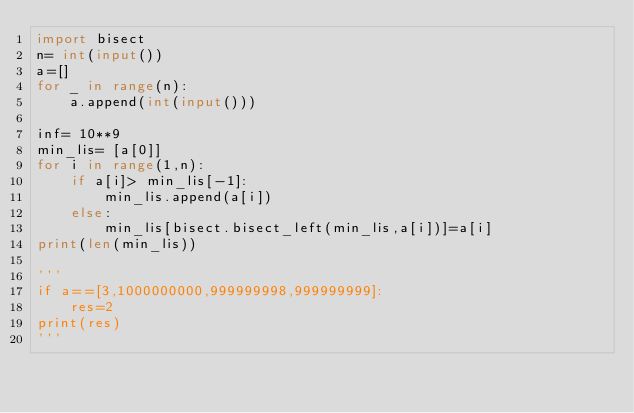Convert code to text. <code><loc_0><loc_0><loc_500><loc_500><_Python_>import bisect
n= int(input())
a=[]
for _ in range(n):
    a.append(int(input()))

inf= 10**9
min_lis= [a[0]]
for i in range(1,n):
    if a[i]> min_lis[-1]:
        min_lis.append(a[i])
    else:
        min_lis[bisect.bisect_left(min_lis,a[i])]=a[i]
print(len(min_lis))
    
'''
if a==[3,1000000000,999999998,999999999]:
    res=2
print(res)
'''
</code> 